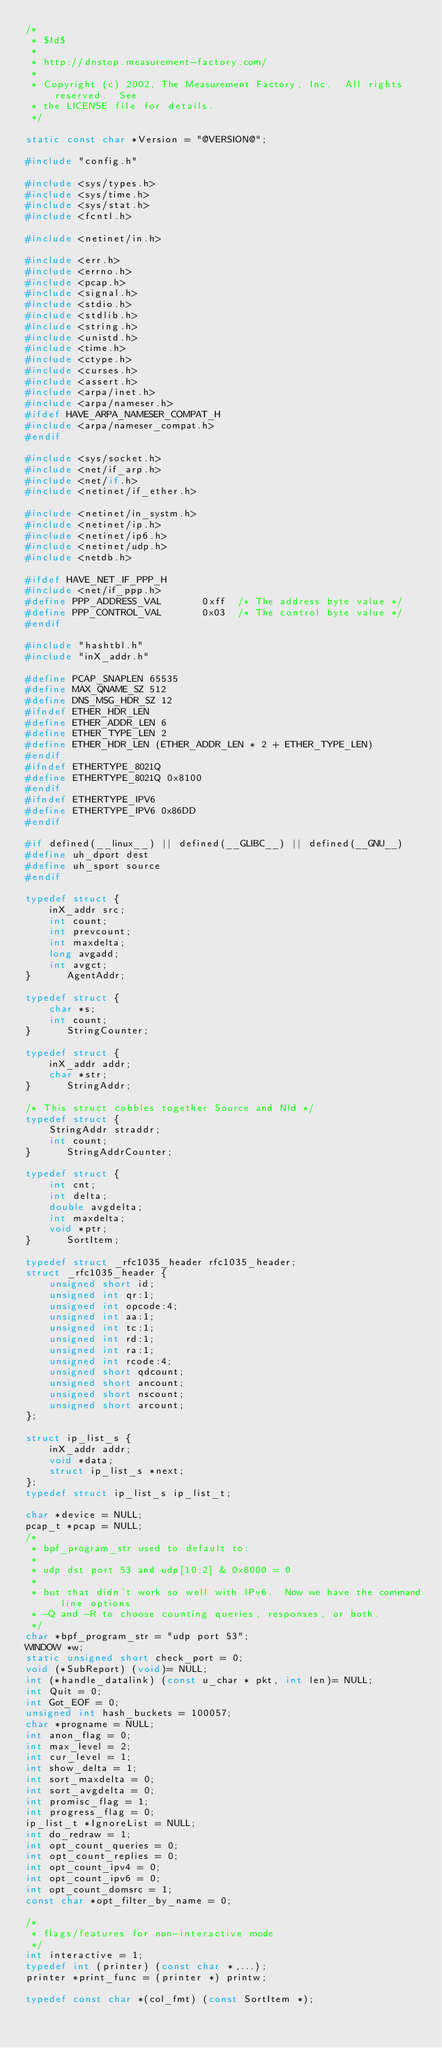<code> <loc_0><loc_0><loc_500><loc_500><_C_>/*
 * $Id$
 * 
 * http://dnstop.measurement-factory.com/
 * 
 * Copyright (c) 2002, The Measurement Factory, Inc.  All rights reserved.  See
 * the LICENSE file for details.
 */

static const char *Version = "@VERSION@";

#include "config.h"

#include <sys/types.h>
#include <sys/time.h>
#include <sys/stat.h>
#include <fcntl.h>

#include <netinet/in.h>

#include <err.h>
#include <errno.h>
#include <pcap.h>
#include <signal.h>
#include <stdio.h>
#include <stdlib.h>
#include <string.h>
#include <unistd.h>
#include <time.h>
#include <ctype.h>
#include <curses.h>
#include <assert.h>
#include <arpa/inet.h>
#include <arpa/nameser.h>
#ifdef HAVE_ARPA_NAMESER_COMPAT_H
#include <arpa/nameser_compat.h>
#endif

#include <sys/socket.h>
#include <net/if_arp.h>
#include <net/if.h>
#include <netinet/if_ether.h>

#include <netinet/in_systm.h>
#include <netinet/ip.h>
#include <netinet/ip6.h>
#include <netinet/udp.h>
#include <netdb.h>

#ifdef HAVE_NET_IF_PPP_H
#include <net/if_ppp.h>
#define PPP_ADDRESS_VAL       0xff	/* The address byte value */
#define PPP_CONTROL_VAL       0x03	/* The control byte value */
#endif

#include "hashtbl.h"
#include "inX_addr.h"

#define PCAP_SNAPLEN 65535
#define MAX_QNAME_SZ 512
#define DNS_MSG_HDR_SZ 12
#ifndef ETHER_HDR_LEN
#define ETHER_ADDR_LEN 6
#define ETHER_TYPE_LEN 2
#define ETHER_HDR_LEN (ETHER_ADDR_LEN * 2 + ETHER_TYPE_LEN)
#endif
#ifndef ETHERTYPE_8021Q
#define ETHERTYPE_8021Q 0x8100
#endif
#ifndef ETHERTYPE_IPV6
#define ETHERTYPE_IPV6 0x86DD
#endif

#if defined(__linux__) || defined(__GLIBC__) || defined(__GNU__)
#define uh_dport dest
#define uh_sport source
#endif

typedef struct {
    inX_addr src;
    int count;
    int prevcount;
    int maxdelta;
    long avgadd;
    int avgct;
}      AgentAddr;

typedef struct {
    char *s;
    int count;
}      StringCounter;

typedef struct {
    inX_addr addr;
    char *str;
}      StringAddr;

/* This struct cobbles together Source and Nld */
typedef struct {
    StringAddr straddr;
    int count;
}      StringAddrCounter;

typedef struct {
    int cnt;
    int delta;
    double avgdelta;
    int maxdelta;
    void *ptr;
}      SortItem;

typedef struct _rfc1035_header rfc1035_header;
struct _rfc1035_header {
    unsigned short id;
    unsigned int qr:1;
    unsigned int opcode:4;
    unsigned int aa:1;
    unsigned int tc:1;
    unsigned int rd:1;
    unsigned int ra:1;
    unsigned int rcode:4;
    unsigned short qdcount;
    unsigned short ancount;
    unsigned short nscount;
    unsigned short arcount;
};

struct ip_list_s {
    inX_addr addr;
    void *data;
    struct ip_list_s *next;
};
typedef struct ip_list_s ip_list_t;

char *device = NULL;
pcap_t *pcap = NULL;
/*
 * bpf_program_str used to default to:
 * 
 * udp dst port 53 and udp[10:2] & 0x8000 = 0
 * 
 * but that didn't work so well with IPv6.  Now we have the command line options
 * -Q and -R to choose counting queries, responses, or both.
 */
char *bpf_program_str = "udp port 53";
WINDOW *w;
static unsigned short check_port = 0;
void (*SubReport) (void)= NULL;
int (*handle_datalink) (const u_char * pkt, int len)= NULL;
int Quit = 0;
int Got_EOF = 0;
unsigned int hash_buckets = 100057;
char *progname = NULL;
int anon_flag = 0;
int max_level = 2;
int cur_level = 1;
int show_delta = 1;
int sort_maxdelta = 0;
int sort_avgdelta = 0;
int promisc_flag = 1;
int progress_flag = 0;
ip_list_t *IgnoreList = NULL;
int do_redraw = 1;
int opt_count_queries = 0;
int opt_count_replies = 0;
int opt_count_ipv4 = 0;
int opt_count_ipv6 = 0;
int opt_count_domsrc = 1;
const char *opt_filter_by_name = 0;

/*
 * flags/features for non-interactive mode
 */
int interactive = 1;
typedef int (printer) (const char *,...);
printer *print_func = (printer *) printw;

typedef const char *(col_fmt) (const SortItem *);</code> 